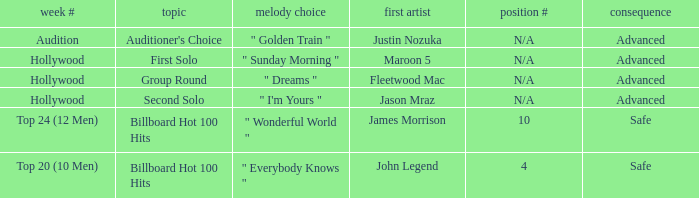What are the outcomes for the song "golden train"? Advanced. Would you mind parsing the complete table? {'header': ['week #', 'topic', 'melody choice', 'first artist', 'position #', 'consequence'], 'rows': [['Audition', "Auditioner's Choice", '" Golden Train "', 'Justin Nozuka', 'N/A', 'Advanced'], ['Hollywood', 'First Solo', '" Sunday Morning "', 'Maroon 5', 'N/A', 'Advanced'], ['Hollywood', 'Group Round', '" Dreams "', 'Fleetwood Mac', 'N/A', 'Advanced'], ['Hollywood', 'Second Solo', '" I\'m Yours "', 'Jason Mraz', 'N/A', 'Advanced'], ['Top 24 (12 Men)', 'Billboard Hot 100 Hits', '" Wonderful World "', 'James Morrison', '10', 'Safe'], ['Top 20 (10 Men)', 'Billboard Hot 100 Hits', '" Everybody Knows "', 'John Legend', '4', 'Safe']]} 